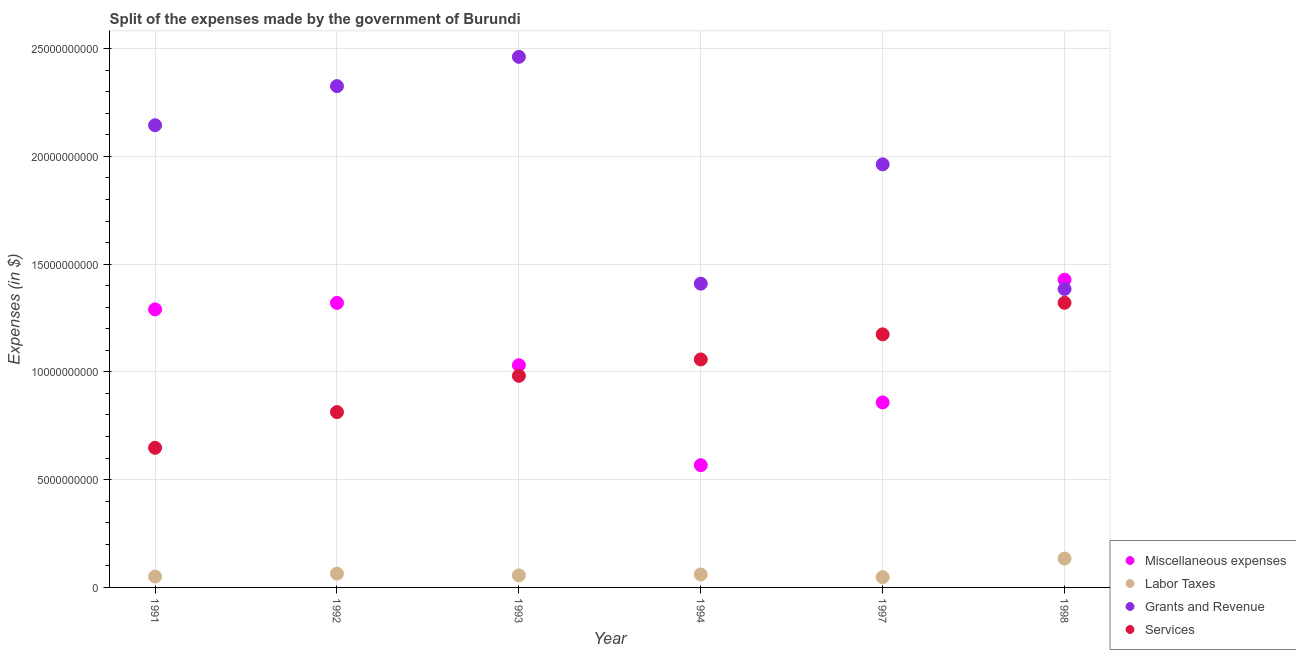Is the number of dotlines equal to the number of legend labels?
Your response must be concise. Yes. What is the amount spent on miscellaneous expenses in 1994?
Offer a very short reply. 5.67e+09. Across all years, what is the maximum amount spent on services?
Your answer should be very brief. 1.32e+1. Across all years, what is the minimum amount spent on services?
Offer a very short reply. 6.48e+09. In which year was the amount spent on grants and revenue minimum?
Your answer should be very brief. 1998. What is the total amount spent on services in the graph?
Provide a short and direct response. 6.00e+1. What is the difference between the amount spent on services in 1992 and that in 1997?
Keep it short and to the point. -3.61e+09. What is the difference between the amount spent on miscellaneous expenses in 1994 and the amount spent on services in 1998?
Keep it short and to the point. -7.53e+09. What is the average amount spent on miscellaneous expenses per year?
Your answer should be very brief. 1.08e+1. In the year 1992, what is the difference between the amount spent on labor taxes and amount spent on grants and revenue?
Offer a very short reply. -2.26e+1. In how many years, is the amount spent on miscellaneous expenses greater than 15000000000 $?
Your response must be concise. 0. What is the ratio of the amount spent on miscellaneous expenses in 1994 to that in 1997?
Provide a short and direct response. 0.66. Is the difference between the amount spent on labor taxes in 1994 and 1997 greater than the difference between the amount spent on services in 1994 and 1997?
Your response must be concise. Yes. What is the difference between the highest and the second highest amount spent on labor taxes?
Provide a succinct answer. 7.01e+08. What is the difference between the highest and the lowest amount spent on grants and revenue?
Ensure brevity in your answer.  1.08e+1. In how many years, is the amount spent on labor taxes greater than the average amount spent on labor taxes taken over all years?
Offer a terse response. 1. Is it the case that in every year, the sum of the amount spent on miscellaneous expenses and amount spent on services is greater than the sum of amount spent on grants and revenue and amount spent on labor taxes?
Provide a succinct answer. No. Is it the case that in every year, the sum of the amount spent on miscellaneous expenses and amount spent on labor taxes is greater than the amount spent on grants and revenue?
Offer a terse response. No. Is the amount spent on labor taxes strictly greater than the amount spent on miscellaneous expenses over the years?
Offer a very short reply. No. What is the difference between two consecutive major ticks on the Y-axis?
Provide a succinct answer. 5.00e+09. Are the values on the major ticks of Y-axis written in scientific E-notation?
Your answer should be compact. No. Does the graph contain any zero values?
Ensure brevity in your answer.  No. Does the graph contain grids?
Offer a terse response. Yes. How many legend labels are there?
Your answer should be very brief. 4. What is the title of the graph?
Offer a very short reply. Split of the expenses made by the government of Burundi. What is the label or title of the X-axis?
Offer a terse response. Year. What is the label or title of the Y-axis?
Provide a short and direct response. Expenses (in $). What is the Expenses (in $) of Miscellaneous expenses in 1991?
Your answer should be compact. 1.29e+1. What is the Expenses (in $) of Labor Taxes in 1991?
Provide a succinct answer. 5.03e+08. What is the Expenses (in $) of Grants and Revenue in 1991?
Ensure brevity in your answer.  2.14e+1. What is the Expenses (in $) of Services in 1991?
Give a very brief answer. 6.48e+09. What is the Expenses (in $) of Miscellaneous expenses in 1992?
Your answer should be compact. 1.32e+1. What is the Expenses (in $) in Labor Taxes in 1992?
Ensure brevity in your answer.  6.41e+08. What is the Expenses (in $) of Grants and Revenue in 1992?
Provide a short and direct response. 2.33e+1. What is the Expenses (in $) of Services in 1992?
Keep it short and to the point. 8.13e+09. What is the Expenses (in $) in Miscellaneous expenses in 1993?
Provide a short and direct response. 1.03e+1. What is the Expenses (in $) in Labor Taxes in 1993?
Your answer should be very brief. 5.60e+08. What is the Expenses (in $) of Grants and Revenue in 1993?
Your answer should be compact. 2.46e+1. What is the Expenses (in $) in Services in 1993?
Make the answer very short. 9.82e+09. What is the Expenses (in $) in Miscellaneous expenses in 1994?
Keep it short and to the point. 5.67e+09. What is the Expenses (in $) in Labor Taxes in 1994?
Provide a short and direct response. 6.03e+08. What is the Expenses (in $) in Grants and Revenue in 1994?
Ensure brevity in your answer.  1.41e+1. What is the Expenses (in $) of Services in 1994?
Give a very brief answer. 1.06e+1. What is the Expenses (in $) of Miscellaneous expenses in 1997?
Provide a short and direct response. 8.58e+09. What is the Expenses (in $) in Labor Taxes in 1997?
Provide a succinct answer. 4.75e+08. What is the Expenses (in $) of Grants and Revenue in 1997?
Your answer should be compact. 1.96e+1. What is the Expenses (in $) in Services in 1997?
Your answer should be compact. 1.17e+1. What is the Expenses (in $) in Miscellaneous expenses in 1998?
Provide a short and direct response. 1.43e+1. What is the Expenses (in $) in Labor Taxes in 1998?
Your answer should be compact. 1.34e+09. What is the Expenses (in $) in Grants and Revenue in 1998?
Provide a succinct answer. 1.38e+1. What is the Expenses (in $) of Services in 1998?
Ensure brevity in your answer.  1.32e+1. Across all years, what is the maximum Expenses (in $) of Miscellaneous expenses?
Provide a short and direct response. 1.43e+1. Across all years, what is the maximum Expenses (in $) of Labor Taxes?
Make the answer very short. 1.34e+09. Across all years, what is the maximum Expenses (in $) in Grants and Revenue?
Keep it short and to the point. 2.46e+1. Across all years, what is the maximum Expenses (in $) of Services?
Your answer should be very brief. 1.32e+1. Across all years, what is the minimum Expenses (in $) of Miscellaneous expenses?
Give a very brief answer. 5.67e+09. Across all years, what is the minimum Expenses (in $) of Labor Taxes?
Your answer should be compact. 4.75e+08. Across all years, what is the minimum Expenses (in $) of Grants and Revenue?
Give a very brief answer. 1.38e+1. Across all years, what is the minimum Expenses (in $) of Services?
Offer a terse response. 6.48e+09. What is the total Expenses (in $) in Miscellaneous expenses in the graph?
Provide a short and direct response. 6.49e+1. What is the total Expenses (in $) in Labor Taxes in the graph?
Make the answer very short. 4.12e+09. What is the total Expenses (in $) of Grants and Revenue in the graph?
Your answer should be compact. 1.17e+11. What is the total Expenses (in $) of Services in the graph?
Make the answer very short. 6.00e+1. What is the difference between the Expenses (in $) of Miscellaneous expenses in 1991 and that in 1992?
Keep it short and to the point. -3.00e+08. What is the difference between the Expenses (in $) of Labor Taxes in 1991 and that in 1992?
Your answer should be compact. -1.38e+08. What is the difference between the Expenses (in $) of Grants and Revenue in 1991 and that in 1992?
Give a very brief answer. -1.81e+09. What is the difference between the Expenses (in $) in Services in 1991 and that in 1992?
Ensure brevity in your answer.  -1.66e+09. What is the difference between the Expenses (in $) of Miscellaneous expenses in 1991 and that in 1993?
Provide a succinct answer. 2.59e+09. What is the difference between the Expenses (in $) in Labor Taxes in 1991 and that in 1993?
Offer a very short reply. -5.70e+07. What is the difference between the Expenses (in $) of Grants and Revenue in 1991 and that in 1993?
Your answer should be compact. -3.17e+09. What is the difference between the Expenses (in $) in Services in 1991 and that in 1993?
Your answer should be very brief. -3.34e+09. What is the difference between the Expenses (in $) in Miscellaneous expenses in 1991 and that in 1994?
Offer a terse response. 7.23e+09. What is the difference between the Expenses (in $) in Labor Taxes in 1991 and that in 1994?
Ensure brevity in your answer.  -1.00e+08. What is the difference between the Expenses (in $) of Grants and Revenue in 1991 and that in 1994?
Offer a terse response. 7.35e+09. What is the difference between the Expenses (in $) of Services in 1991 and that in 1994?
Provide a succinct answer. -4.10e+09. What is the difference between the Expenses (in $) of Miscellaneous expenses in 1991 and that in 1997?
Your answer should be compact. 4.32e+09. What is the difference between the Expenses (in $) in Labor Taxes in 1991 and that in 1997?
Give a very brief answer. 2.80e+07. What is the difference between the Expenses (in $) of Grants and Revenue in 1991 and that in 1997?
Make the answer very short. 1.81e+09. What is the difference between the Expenses (in $) of Services in 1991 and that in 1997?
Ensure brevity in your answer.  -5.26e+09. What is the difference between the Expenses (in $) in Miscellaneous expenses in 1991 and that in 1998?
Offer a terse response. -1.38e+09. What is the difference between the Expenses (in $) of Labor Taxes in 1991 and that in 1998?
Offer a very short reply. -8.39e+08. What is the difference between the Expenses (in $) in Grants and Revenue in 1991 and that in 1998?
Offer a very short reply. 7.60e+09. What is the difference between the Expenses (in $) in Services in 1991 and that in 1998?
Your answer should be compact. -6.73e+09. What is the difference between the Expenses (in $) in Miscellaneous expenses in 1992 and that in 1993?
Offer a very short reply. 2.89e+09. What is the difference between the Expenses (in $) of Labor Taxes in 1992 and that in 1993?
Your answer should be compact. 8.10e+07. What is the difference between the Expenses (in $) in Grants and Revenue in 1992 and that in 1993?
Your answer should be compact. -1.36e+09. What is the difference between the Expenses (in $) in Services in 1992 and that in 1993?
Ensure brevity in your answer.  -1.68e+09. What is the difference between the Expenses (in $) in Miscellaneous expenses in 1992 and that in 1994?
Offer a terse response. 7.53e+09. What is the difference between the Expenses (in $) in Labor Taxes in 1992 and that in 1994?
Make the answer very short. 3.80e+07. What is the difference between the Expenses (in $) of Grants and Revenue in 1992 and that in 1994?
Provide a short and direct response. 9.16e+09. What is the difference between the Expenses (in $) of Services in 1992 and that in 1994?
Offer a very short reply. -2.44e+09. What is the difference between the Expenses (in $) in Miscellaneous expenses in 1992 and that in 1997?
Offer a terse response. 4.62e+09. What is the difference between the Expenses (in $) in Labor Taxes in 1992 and that in 1997?
Make the answer very short. 1.66e+08. What is the difference between the Expenses (in $) of Grants and Revenue in 1992 and that in 1997?
Provide a succinct answer. 3.63e+09. What is the difference between the Expenses (in $) in Services in 1992 and that in 1997?
Your answer should be compact. -3.61e+09. What is the difference between the Expenses (in $) of Miscellaneous expenses in 1992 and that in 1998?
Your answer should be very brief. -1.08e+09. What is the difference between the Expenses (in $) in Labor Taxes in 1992 and that in 1998?
Give a very brief answer. -7.01e+08. What is the difference between the Expenses (in $) of Grants and Revenue in 1992 and that in 1998?
Offer a very short reply. 9.41e+09. What is the difference between the Expenses (in $) in Services in 1992 and that in 1998?
Your answer should be very brief. -5.07e+09. What is the difference between the Expenses (in $) in Miscellaneous expenses in 1993 and that in 1994?
Provide a short and direct response. 4.64e+09. What is the difference between the Expenses (in $) in Labor Taxes in 1993 and that in 1994?
Make the answer very short. -4.30e+07. What is the difference between the Expenses (in $) of Grants and Revenue in 1993 and that in 1994?
Provide a short and direct response. 1.05e+1. What is the difference between the Expenses (in $) of Services in 1993 and that in 1994?
Your response must be concise. -7.59e+08. What is the difference between the Expenses (in $) in Miscellaneous expenses in 1993 and that in 1997?
Your answer should be very brief. 1.72e+09. What is the difference between the Expenses (in $) in Labor Taxes in 1993 and that in 1997?
Make the answer very short. 8.50e+07. What is the difference between the Expenses (in $) in Grants and Revenue in 1993 and that in 1997?
Your answer should be compact. 4.99e+09. What is the difference between the Expenses (in $) of Services in 1993 and that in 1997?
Provide a succinct answer. -1.92e+09. What is the difference between the Expenses (in $) of Miscellaneous expenses in 1993 and that in 1998?
Provide a short and direct response. -3.97e+09. What is the difference between the Expenses (in $) in Labor Taxes in 1993 and that in 1998?
Offer a very short reply. -7.82e+08. What is the difference between the Expenses (in $) of Grants and Revenue in 1993 and that in 1998?
Give a very brief answer. 1.08e+1. What is the difference between the Expenses (in $) in Services in 1993 and that in 1998?
Offer a terse response. -3.39e+09. What is the difference between the Expenses (in $) in Miscellaneous expenses in 1994 and that in 1997?
Keep it short and to the point. -2.91e+09. What is the difference between the Expenses (in $) in Labor Taxes in 1994 and that in 1997?
Make the answer very short. 1.28e+08. What is the difference between the Expenses (in $) in Grants and Revenue in 1994 and that in 1997?
Make the answer very short. -5.54e+09. What is the difference between the Expenses (in $) of Services in 1994 and that in 1997?
Make the answer very short. -1.16e+09. What is the difference between the Expenses (in $) of Miscellaneous expenses in 1994 and that in 1998?
Provide a succinct answer. -8.60e+09. What is the difference between the Expenses (in $) of Labor Taxes in 1994 and that in 1998?
Your answer should be very brief. -7.39e+08. What is the difference between the Expenses (in $) in Grants and Revenue in 1994 and that in 1998?
Provide a short and direct response. 2.46e+08. What is the difference between the Expenses (in $) of Services in 1994 and that in 1998?
Ensure brevity in your answer.  -2.63e+09. What is the difference between the Expenses (in $) in Miscellaneous expenses in 1997 and that in 1998?
Keep it short and to the point. -5.69e+09. What is the difference between the Expenses (in $) of Labor Taxes in 1997 and that in 1998?
Give a very brief answer. -8.67e+08. What is the difference between the Expenses (in $) in Grants and Revenue in 1997 and that in 1998?
Your answer should be compact. 5.78e+09. What is the difference between the Expenses (in $) in Services in 1997 and that in 1998?
Provide a succinct answer. -1.46e+09. What is the difference between the Expenses (in $) of Miscellaneous expenses in 1991 and the Expenses (in $) of Labor Taxes in 1992?
Offer a terse response. 1.23e+1. What is the difference between the Expenses (in $) in Miscellaneous expenses in 1991 and the Expenses (in $) in Grants and Revenue in 1992?
Provide a succinct answer. -1.04e+1. What is the difference between the Expenses (in $) in Miscellaneous expenses in 1991 and the Expenses (in $) in Services in 1992?
Give a very brief answer. 4.77e+09. What is the difference between the Expenses (in $) of Labor Taxes in 1991 and the Expenses (in $) of Grants and Revenue in 1992?
Your answer should be very brief. -2.28e+1. What is the difference between the Expenses (in $) of Labor Taxes in 1991 and the Expenses (in $) of Services in 1992?
Ensure brevity in your answer.  -7.63e+09. What is the difference between the Expenses (in $) of Grants and Revenue in 1991 and the Expenses (in $) of Services in 1992?
Make the answer very short. 1.33e+1. What is the difference between the Expenses (in $) in Miscellaneous expenses in 1991 and the Expenses (in $) in Labor Taxes in 1993?
Offer a terse response. 1.23e+1. What is the difference between the Expenses (in $) in Miscellaneous expenses in 1991 and the Expenses (in $) in Grants and Revenue in 1993?
Make the answer very short. -1.17e+1. What is the difference between the Expenses (in $) of Miscellaneous expenses in 1991 and the Expenses (in $) of Services in 1993?
Make the answer very short. 3.08e+09. What is the difference between the Expenses (in $) in Labor Taxes in 1991 and the Expenses (in $) in Grants and Revenue in 1993?
Your response must be concise. -2.41e+1. What is the difference between the Expenses (in $) in Labor Taxes in 1991 and the Expenses (in $) in Services in 1993?
Your answer should be very brief. -9.32e+09. What is the difference between the Expenses (in $) of Grants and Revenue in 1991 and the Expenses (in $) of Services in 1993?
Provide a succinct answer. 1.16e+1. What is the difference between the Expenses (in $) of Miscellaneous expenses in 1991 and the Expenses (in $) of Labor Taxes in 1994?
Ensure brevity in your answer.  1.23e+1. What is the difference between the Expenses (in $) in Miscellaneous expenses in 1991 and the Expenses (in $) in Grants and Revenue in 1994?
Your answer should be compact. -1.19e+09. What is the difference between the Expenses (in $) in Miscellaneous expenses in 1991 and the Expenses (in $) in Services in 1994?
Your answer should be very brief. 2.32e+09. What is the difference between the Expenses (in $) of Labor Taxes in 1991 and the Expenses (in $) of Grants and Revenue in 1994?
Keep it short and to the point. -1.36e+1. What is the difference between the Expenses (in $) of Labor Taxes in 1991 and the Expenses (in $) of Services in 1994?
Make the answer very short. -1.01e+1. What is the difference between the Expenses (in $) of Grants and Revenue in 1991 and the Expenses (in $) of Services in 1994?
Make the answer very short. 1.09e+1. What is the difference between the Expenses (in $) of Miscellaneous expenses in 1991 and the Expenses (in $) of Labor Taxes in 1997?
Your answer should be compact. 1.24e+1. What is the difference between the Expenses (in $) in Miscellaneous expenses in 1991 and the Expenses (in $) in Grants and Revenue in 1997?
Your response must be concise. -6.73e+09. What is the difference between the Expenses (in $) in Miscellaneous expenses in 1991 and the Expenses (in $) in Services in 1997?
Give a very brief answer. 1.16e+09. What is the difference between the Expenses (in $) in Labor Taxes in 1991 and the Expenses (in $) in Grants and Revenue in 1997?
Make the answer very short. -1.91e+1. What is the difference between the Expenses (in $) in Labor Taxes in 1991 and the Expenses (in $) in Services in 1997?
Provide a succinct answer. -1.12e+1. What is the difference between the Expenses (in $) in Grants and Revenue in 1991 and the Expenses (in $) in Services in 1997?
Offer a terse response. 9.70e+09. What is the difference between the Expenses (in $) in Miscellaneous expenses in 1991 and the Expenses (in $) in Labor Taxes in 1998?
Your response must be concise. 1.16e+1. What is the difference between the Expenses (in $) of Miscellaneous expenses in 1991 and the Expenses (in $) of Grants and Revenue in 1998?
Your response must be concise. -9.47e+08. What is the difference between the Expenses (in $) in Miscellaneous expenses in 1991 and the Expenses (in $) in Services in 1998?
Offer a terse response. -3.05e+08. What is the difference between the Expenses (in $) in Labor Taxes in 1991 and the Expenses (in $) in Grants and Revenue in 1998?
Provide a succinct answer. -1.33e+1. What is the difference between the Expenses (in $) in Labor Taxes in 1991 and the Expenses (in $) in Services in 1998?
Offer a terse response. -1.27e+1. What is the difference between the Expenses (in $) in Grants and Revenue in 1991 and the Expenses (in $) in Services in 1998?
Your answer should be very brief. 8.24e+09. What is the difference between the Expenses (in $) of Miscellaneous expenses in 1992 and the Expenses (in $) of Labor Taxes in 1993?
Give a very brief answer. 1.26e+1. What is the difference between the Expenses (in $) in Miscellaneous expenses in 1992 and the Expenses (in $) in Grants and Revenue in 1993?
Your response must be concise. -1.14e+1. What is the difference between the Expenses (in $) in Miscellaneous expenses in 1992 and the Expenses (in $) in Services in 1993?
Give a very brief answer. 3.38e+09. What is the difference between the Expenses (in $) in Labor Taxes in 1992 and the Expenses (in $) in Grants and Revenue in 1993?
Offer a very short reply. -2.40e+1. What is the difference between the Expenses (in $) of Labor Taxes in 1992 and the Expenses (in $) of Services in 1993?
Give a very brief answer. -9.18e+09. What is the difference between the Expenses (in $) of Grants and Revenue in 1992 and the Expenses (in $) of Services in 1993?
Offer a very short reply. 1.34e+1. What is the difference between the Expenses (in $) of Miscellaneous expenses in 1992 and the Expenses (in $) of Labor Taxes in 1994?
Offer a very short reply. 1.26e+1. What is the difference between the Expenses (in $) of Miscellaneous expenses in 1992 and the Expenses (in $) of Grants and Revenue in 1994?
Ensure brevity in your answer.  -8.93e+08. What is the difference between the Expenses (in $) in Miscellaneous expenses in 1992 and the Expenses (in $) in Services in 1994?
Keep it short and to the point. 2.62e+09. What is the difference between the Expenses (in $) in Labor Taxes in 1992 and the Expenses (in $) in Grants and Revenue in 1994?
Offer a very short reply. -1.35e+1. What is the difference between the Expenses (in $) of Labor Taxes in 1992 and the Expenses (in $) of Services in 1994?
Provide a short and direct response. -9.94e+09. What is the difference between the Expenses (in $) in Grants and Revenue in 1992 and the Expenses (in $) in Services in 1994?
Offer a very short reply. 1.27e+1. What is the difference between the Expenses (in $) in Miscellaneous expenses in 1992 and the Expenses (in $) in Labor Taxes in 1997?
Make the answer very short. 1.27e+1. What is the difference between the Expenses (in $) in Miscellaneous expenses in 1992 and the Expenses (in $) in Grants and Revenue in 1997?
Your answer should be compact. -6.43e+09. What is the difference between the Expenses (in $) of Miscellaneous expenses in 1992 and the Expenses (in $) of Services in 1997?
Make the answer very short. 1.46e+09. What is the difference between the Expenses (in $) of Labor Taxes in 1992 and the Expenses (in $) of Grants and Revenue in 1997?
Provide a succinct answer. -1.90e+1. What is the difference between the Expenses (in $) of Labor Taxes in 1992 and the Expenses (in $) of Services in 1997?
Offer a very short reply. -1.11e+1. What is the difference between the Expenses (in $) in Grants and Revenue in 1992 and the Expenses (in $) in Services in 1997?
Make the answer very short. 1.15e+1. What is the difference between the Expenses (in $) of Miscellaneous expenses in 1992 and the Expenses (in $) of Labor Taxes in 1998?
Your answer should be compact. 1.19e+1. What is the difference between the Expenses (in $) in Miscellaneous expenses in 1992 and the Expenses (in $) in Grants and Revenue in 1998?
Provide a succinct answer. -6.47e+08. What is the difference between the Expenses (in $) in Miscellaneous expenses in 1992 and the Expenses (in $) in Services in 1998?
Offer a very short reply. -5.00e+06. What is the difference between the Expenses (in $) in Labor Taxes in 1992 and the Expenses (in $) in Grants and Revenue in 1998?
Give a very brief answer. -1.32e+1. What is the difference between the Expenses (in $) in Labor Taxes in 1992 and the Expenses (in $) in Services in 1998?
Give a very brief answer. -1.26e+1. What is the difference between the Expenses (in $) in Grants and Revenue in 1992 and the Expenses (in $) in Services in 1998?
Provide a succinct answer. 1.01e+1. What is the difference between the Expenses (in $) of Miscellaneous expenses in 1993 and the Expenses (in $) of Labor Taxes in 1994?
Your answer should be very brief. 9.70e+09. What is the difference between the Expenses (in $) in Miscellaneous expenses in 1993 and the Expenses (in $) in Grants and Revenue in 1994?
Your response must be concise. -3.78e+09. What is the difference between the Expenses (in $) of Miscellaneous expenses in 1993 and the Expenses (in $) of Services in 1994?
Your answer should be compact. -2.69e+08. What is the difference between the Expenses (in $) in Labor Taxes in 1993 and the Expenses (in $) in Grants and Revenue in 1994?
Make the answer very short. -1.35e+1. What is the difference between the Expenses (in $) of Labor Taxes in 1993 and the Expenses (in $) of Services in 1994?
Keep it short and to the point. -1.00e+1. What is the difference between the Expenses (in $) of Grants and Revenue in 1993 and the Expenses (in $) of Services in 1994?
Offer a very short reply. 1.40e+1. What is the difference between the Expenses (in $) in Miscellaneous expenses in 1993 and the Expenses (in $) in Labor Taxes in 1997?
Your answer should be compact. 9.83e+09. What is the difference between the Expenses (in $) in Miscellaneous expenses in 1993 and the Expenses (in $) in Grants and Revenue in 1997?
Your answer should be compact. -9.32e+09. What is the difference between the Expenses (in $) of Miscellaneous expenses in 1993 and the Expenses (in $) of Services in 1997?
Provide a succinct answer. -1.43e+09. What is the difference between the Expenses (in $) of Labor Taxes in 1993 and the Expenses (in $) of Grants and Revenue in 1997?
Give a very brief answer. -1.91e+1. What is the difference between the Expenses (in $) of Labor Taxes in 1993 and the Expenses (in $) of Services in 1997?
Keep it short and to the point. -1.12e+1. What is the difference between the Expenses (in $) of Grants and Revenue in 1993 and the Expenses (in $) of Services in 1997?
Offer a very short reply. 1.29e+1. What is the difference between the Expenses (in $) in Miscellaneous expenses in 1993 and the Expenses (in $) in Labor Taxes in 1998?
Your answer should be very brief. 8.97e+09. What is the difference between the Expenses (in $) of Miscellaneous expenses in 1993 and the Expenses (in $) of Grants and Revenue in 1998?
Your answer should be compact. -3.54e+09. What is the difference between the Expenses (in $) in Miscellaneous expenses in 1993 and the Expenses (in $) in Services in 1998?
Your answer should be very brief. -2.90e+09. What is the difference between the Expenses (in $) of Labor Taxes in 1993 and the Expenses (in $) of Grants and Revenue in 1998?
Give a very brief answer. -1.33e+1. What is the difference between the Expenses (in $) of Labor Taxes in 1993 and the Expenses (in $) of Services in 1998?
Provide a short and direct response. -1.26e+1. What is the difference between the Expenses (in $) in Grants and Revenue in 1993 and the Expenses (in $) in Services in 1998?
Provide a succinct answer. 1.14e+1. What is the difference between the Expenses (in $) in Miscellaneous expenses in 1994 and the Expenses (in $) in Labor Taxes in 1997?
Provide a short and direct response. 5.20e+09. What is the difference between the Expenses (in $) of Miscellaneous expenses in 1994 and the Expenses (in $) of Grants and Revenue in 1997?
Your answer should be very brief. -1.40e+1. What is the difference between the Expenses (in $) of Miscellaneous expenses in 1994 and the Expenses (in $) of Services in 1997?
Offer a very short reply. -6.07e+09. What is the difference between the Expenses (in $) of Labor Taxes in 1994 and the Expenses (in $) of Grants and Revenue in 1997?
Give a very brief answer. -1.90e+1. What is the difference between the Expenses (in $) of Labor Taxes in 1994 and the Expenses (in $) of Services in 1997?
Your answer should be compact. -1.11e+1. What is the difference between the Expenses (in $) in Grants and Revenue in 1994 and the Expenses (in $) in Services in 1997?
Your answer should be compact. 2.35e+09. What is the difference between the Expenses (in $) of Miscellaneous expenses in 1994 and the Expenses (in $) of Labor Taxes in 1998?
Your answer should be compact. 4.33e+09. What is the difference between the Expenses (in $) in Miscellaneous expenses in 1994 and the Expenses (in $) in Grants and Revenue in 1998?
Keep it short and to the point. -8.18e+09. What is the difference between the Expenses (in $) of Miscellaneous expenses in 1994 and the Expenses (in $) of Services in 1998?
Make the answer very short. -7.53e+09. What is the difference between the Expenses (in $) of Labor Taxes in 1994 and the Expenses (in $) of Grants and Revenue in 1998?
Provide a short and direct response. -1.32e+1. What is the difference between the Expenses (in $) in Labor Taxes in 1994 and the Expenses (in $) in Services in 1998?
Make the answer very short. -1.26e+1. What is the difference between the Expenses (in $) of Grants and Revenue in 1994 and the Expenses (in $) of Services in 1998?
Your response must be concise. 8.88e+08. What is the difference between the Expenses (in $) of Miscellaneous expenses in 1997 and the Expenses (in $) of Labor Taxes in 1998?
Offer a very short reply. 7.24e+09. What is the difference between the Expenses (in $) in Miscellaneous expenses in 1997 and the Expenses (in $) in Grants and Revenue in 1998?
Provide a succinct answer. -5.26e+09. What is the difference between the Expenses (in $) in Miscellaneous expenses in 1997 and the Expenses (in $) in Services in 1998?
Provide a short and direct response. -4.62e+09. What is the difference between the Expenses (in $) of Labor Taxes in 1997 and the Expenses (in $) of Grants and Revenue in 1998?
Provide a succinct answer. -1.34e+1. What is the difference between the Expenses (in $) of Labor Taxes in 1997 and the Expenses (in $) of Services in 1998?
Offer a very short reply. -1.27e+1. What is the difference between the Expenses (in $) of Grants and Revenue in 1997 and the Expenses (in $) of Services in 1998?
Offer a terse response. 6.42e+09. What is the average Expenses (in $) of Miscellaneous expenses per year?
Your response must be concise. 1.08e+1. What is the average Expenses (in $) in Labor Taxes per year?
Your answer should be compact. 6.87e+08. What is the average Expenses (in $) in Grants and Revenue per year?
Provide a short and direct response. 1.95e+1. What is the average Expenses (in $) in Services per year?
Offer a terse response. 9.99e+09. In the year 1991, what is the difference between the Expenses (in $) in Miscellaneous expenses and Expenses (in $) in Labor Taxes?
Offer a very short reply. 1.24e+1. In the year 1991, what is the difference between the Expenses (in $) of Miscellaneous expenses and Expenses (in $) of Grants and Revenue?
Provide a short and direct response. -8.54e+09. In the year 1991, what is the difference between the Expenses (in $) of Miscellaneous expenses and Expenses (in $) of Services?
Provide a succinct answer. 6.42e+09. In the year 1991, what is the difference between the Expenses (in $) in Labor Taxes and Expenses (in $) in Grants and Revenue?
Your answer should be very brief. -2.09e+1. In the year 1991, what is the difference between the Expenses (in $) of Labor Taxes and Expenses (in $) of Services?
Make the answer very short. -5.98e+09. In the year 1991, what is the difference between the Expenses (in $) in Grants and Revenue and Expenses (in $) in Services?
Your response must be concise. 1.50e+1. In the year 1992, what is the difference between the Expenses (in $) of Miscellaneous expenses and Expenses (in $) of Labor Taxes?
Your answer should be very brief. 1.26e+1. In the year 1992, what is the difference between the Expenses (in $) in Miscellaneous expenses and Expenses (in $) in Grants and Revenue?
Offer a terse response. -1.01e+1. In the year 1992, what is the difference between the Expenses (in $) in Miscellaneous expenses and Expenses (in $) in Services?
Make the answer very short. 5.07e+09. In the year 1992, what is the difference between the Expenses (in $) in Labor Taxes and Expenses (in $) in Grants and Revenue?
Offer a very short reply. -2.26e+1. In the year 1992, what is the difference between the Expenses (in $) of Labor Taxes and Expenses (in $) of Services?
Your answer should be very brief. -7.49e+09. In the year 1992, what is the difference between the Expenses (in $) in Grants and Revenue and Expenses (in $) in Services?
Provide a short and direct response. 1.51e+1. In the year 1993, what is the difference between the Expenses (in $) in Miscellaneous expenses and Expenses (in $) in Labor Taxes?
Ensure brevity in your answer.  9.75e+09. In the year 1993, what is the difference between the Expenses (in $) in Miscellaneous expenses and Expenses (in $) in Grants and Revenue?
Offer a terse response. -1.43e+1. In the year 1993, what is the difference between the Expenses (in $) in Miscellaneous expenses and Expenses (in $) in Services?
Make the answer very short. 4.90e+08. In the year 1993, what is the difference between the Expenses (in $) of Labor Taxes and Expenses (in $) of Grants and Revenue?
Your answer should be compact. -2.41e+1. In the year 1993, what is the difference between the Expenses (in $) in Labor Taxes and Expenses (in $) in Services?
Give a very brief answer. -9.26e+09. In the year 1993, what is the difference between the Expenses (in $) in Grants and Revenue and Expenses (in $) in Services?
Give a very brief answer. 1.48e+1. In the year 1994, what is the difference between the Expenses (in $) in Miscellaneous expenses and Expenses (in $) in Labor Taxes?
Your answer should be compact. 5.07e+09. In the year 1994, what is the difference between the Expenses (in $) in Miscellaneous expenses and Expenses (in $) in Grants and Revenue?
Ensure brevity in your answer.  -8.42e+09. In the year 1994, what is the difference between the Expenses (in $) in Miscellaneous expenses and Expenses (in $) in Services?
Give a very brief answer. -4.90e+09. In the year 1994, what is the difference between the Expenses (in $) in Labor Taxes and Expenses (in $) in Grants and Revenue?
Provide a short and direct response. -1.35e+1. In the year 1994, what is the difference between the Expenses (in $) in Labor Taxes and Expenses (in $) in Services?
Your response must be concise. -9.97e+09. In the year 1994, what is the difference between the Expenses (in $) in Grants and Revenue and Expenses (in $) in Services?
Ensure brevity in your answer.  3.52e+09. In the year 1997, what is the difference between the Expenses (in $) in Miscellaneous expenses and Expenses (in $) in Labor Taxes?
Ensure brevity in your answer.  8.11e+09. In the year 1997, what is the difference between the Expenses (in $) of Miscellaneous expenses and Expenses (in $) of Grants and Revenue?
Give a very brief answer. -1.10e+1. In the year 1997, what is the difference between the Expenses (in $) in Miscellaneous expenses and Expenses (in $) in Services?
Make the answer very short. -3.16e+09. In the year 1997, what is the difference between the Expenses (in $) of Labor Taxes and Expenses (in $) of Grants and Revenue?
Keep it short and to the point. -1.92e+1. In the year 1997, what is the difference between the Expenses (in $) of Labor Taxes and Expenses (in $) of Services?
Ensure brevity in your answer.  -1.13e+1. In the year 1997, what is the difference between the Expenses (in $) in Grants and Revenue and Expenses (in $) in Services?
Provide a succinct answer. 7.89e+09. In the year 1998, what is the difference between the Expenses (in $) of Miscellaneous expenses and Expenses (in $) of Labor Taxes?
Provide a succinct answer. 1.29e+1. In the year 1998, what is the difference between the Expenses (in $) in Miscellaneous expenses and Expenses (in $) in Grants and Revenue?
Your answer should be compact. 4.28e+08. In the year 1998, what is the difference between the Expenses (in $) of Miscellaneous expenses and Expenses (in $) of Services?
Offer a terse response. 1.07e+09. In the year 1998, what is the difference between the Expenses (in $) in Labor Taxes and Expenses (in $) in Grants and Revenue?
Give a very brief answer. -1.25e+1. In the year 1998, what is the difference between the Expenses (in $) in Labor Taxes and Expenses (in $) in Services?
Your answer should be very brief. -1.19e+1. In the year 1998, what is the difference between the Expenses (in $) in Grants and Revenue and Expenses (in $) in Services?
Make the answer very short. 6.42e+08. What is the ratio of the Expenses (in $) in Miscellaneous expenses in 1991 to that in 1992?
Give a very brief answer. 0.98. What is the ratio of the Expenses (in $) of Labor Taxes in 1991 to that in 1992?
Offer a terse response. 0.78. What is the ratio of the Expenses (in $) in Grants and Revenue in 1991 to that in 1992?
Your answer should be compact. 0.92. What is the ratio of the Expenses (in $) of Services in 1991 to that in 1992?
Keep it short and to the point. 0.8. What is the ratio of the Expenses (in $) in Miscellaneous expenses in 1991 to that in 1993?
Provide a succinct answer. 1.25. What is the ratio of the Expenses (in $) of Labor Taxes in 1991 to that in 1993?
Your answer should be compact. 0.9. What is the ratio of the Expenses (in $) of Grants and Revenue in 1991 to that in 1993?
Your answer should be compact. 0.87. What is the ratio of the Expenses (in $) in Services in 1991 to that in 1993?
Ensure brevity in your answer.  0.66. What is the ratio of the Expenses (in $) in Miscellaneous expenses in 1991 to that in 1994?
Your response must be concise. 2.27. What is the ratio of the Expenses (in $) in Labor Taxes in 1991 to that in 1994?
Provide a short and direct response. 0.83. What is the ratio of the Expenses (in $) in Grants and Revenue in 1991 to that in 1994?
Provide a succinct answer. 1.52. What is the ratio of the Expenses (in $) of Services in 1991 to that in 1994?
Ensure brevity in your answer.  0.61. What is the ratio of the Expenses (in $) in Miscellaneous expenses in 1991 to that in 1997?
Provide a short and direct response. 1.5. What is the ratio of the Expenses (in $) in Labor Taxes in 1991 to that in 1997?
Offer a very short reply. 1.06. What is the ratio of the Expenses (in $) in Grants and Revenue in 1991 to that in 1997?
Offer a very short reply. 1.09. What is the ratio of the Expenses (in $) in Services in 1991 to that in 1997?
Provide a short and direct response. 0.55. What is the ratio of the Expenses (in $) in Miscellaneous expenses in 1991 to that in 1998?
Provide a short and direct response. 0.9. What is the ratio of the Expenses (in $) of Labor Taxes in 1991 to that in 1998?
Your answer should be compact. 0.37. What is the ratio of the Expenses (in $) of Grants and Revenue in 1991 to that in 1998?
Offer a very short reply. 1.55. What is the ratio of the Expenses (in $) of Services in 1991 to that in 1998?
Ensure brevity in your answer.  0.49. What is the ratio of the Expenses (in $) of Miscellaneous expenses in 1992 to that in 1993?
Your response must be concise. 1.28. What is the ratio of the Expenses (in $) in Labor Taxes in 1992 to that in 1993?
Make the answer very short. 1.14. What is the ratio of the Expenses (in $) of Grants and Revenue in 1992 to that in 1993?
Offer a terse response. 0.94. What is the ratio of the Expenses (in $) in Services in 1992 to that in 1993?
Provide a succinct answer. 0.83. What is the ratio of the Expenses (in $) of Miscellaneous expenses in 1992 to that in 1994?
Your answer should be compact. 2.33. What is the ratio of the Expenses (in $) of Labor Taxes in 1992 to that in 1994?
Your answer should be very brief. 1.06. What is the ratio of the Expenses (in $) of Grants and Revenue in 1992 to that in 1994?
Keep it short and to the point. 1.65. What is the ratio of the Expenses (in $) in Services in 1992 to that in 1994?
Offer a terse response. 0.77. What is the ratio of the Expenses (in $) in Miscellaneous expenses in 1992 to that in 1997?
Give a very brief answer. 1.54. What is the ratio of the Expenses (in $) in Labor Taxes in 1992 to that in 1997?
Your answer should be compact. 1.35. What is the ratio of the Expenses (in $) in Grants and Revenue in 1992 to that in 1997?
Your response must be concise. 1.18. What is the ratio of the Expenses (in $) of Services in 1992 to that in 1997?
Provide a short and direct response. 0.69. What is the ratio of the Expenses (in $) of Miscellaneous expenses in 1992 to that in 1998?
Keep it short and to the point. 0.92. What is the ratio of the Expenses (in $) of Labor Taxes in 1992 to that in 1998?
Give a very brief answer. 0.48. What is the ratio of the Expenses (in $) in Grants and Revenue in 1992 to that in 1998?
Your answer should be compact. 1.68. What is the ratio of the Expenses (in $) in Services in 1992 to that in 1998?
Your answer should be compact. 0.62. What is the ratio of the Expenses (in $) of Miscellaneous expenses in 1993 to that in 1994?
Provide a succinct answer. 1.82. What is the ratio of the Expenses (in $) in Labor Taxes in 1993 to that in 1994?
Your response must be concise. 0.93. What is the ratio of the Expenses (in $) of Grants and Revenue in 1993 to that in 1994?
Offer a very short reply. 1.75. What is the ratio of the Expenses (in $) in Services in 1993 to that in 1994?
Make the answer very short. 0.93. What is the ratio of the Expenses (in $) of Miscellaneous expenses in 1993 to that in 1997?
Your response must be concise. 1.2. What is the ratio of the Expenses (in $) of Labor Taxes in 1993 to that in 1997?
Offer a terse response. 1.18. What is the ratio of the Expenses (in $) of Grants and Revenue in 1993 to that in 1997?
Keep it short and to the point. 1.25. What is the ratio of the Expenses (in $) in Services in 1993 to that in 1997?
Offer a terse response. 0.84. What is the ratio of the Expenses (in $) in Miscellaneous expenses in 1993 to that in 1998?
Your answer should be very brief. 0.72. What is the ratio of the Expenses (in $) of Labor Taxes in 1993 to that in 1998?
Keep it short and to the point. 0.42. What is the ratio of the Expenses (in $) in Grants and Revenue in 1993 to that in 1998?
Your response must be concise. 1.78. What is the ratio of the Expenses (in $) of Services in 1993 to that in 1998?
Make the answer very short. 0.74. What is the ratio of the Expenses (in $) in Miscellaneous expenses in 1994 to that in 1997?
Your answer should be compact. 0.66. What is the ratio of the Expenses (in $) of Labor Taxes in 1994 to that in 1997?
Make the answer very short. 1.27. What is the ratio of the Expenses (in $) of Grants and Revenue in 1994 to that in 1997?
Offer a terse response. 0.72. What is the ratio of the Expenses (in $) of Services in 1994 to that in 1997?
Offer a very short reply. 0.9. What is the ratio of the Expenses (in $) in Miscellaneous expenses in 1994 to that in 1998?
Provide a short and direct response. 0.4. What is the ratio of the Expenses (in $) in Labor Taxes in 1994 to that in 1998?
Give a very brief answer. 0.45. What is the ratio of the Expenses (in $) in Grants and Revenue in 1994 to that in 1998?
Offer a terse response. 1.02. What is the ratio of the Expenses (in $) in Services in 1994 to that in 1998?
Ensure brevity in your answer.  0.8. What is the ratio of the Expenses (in $) in Miscellaneous expenses in 1997 to that in 1998?
Your answer should be compact. 0.6. What is the ratio of the Expenses (in $) in Labor Taxes in 1997 to that in 1998?
Offer a terse response. 0.35. What is the ratio of the Expenses (in $) of Grants and Revenue in 1997 to that in 1998?
Your answer should be compact. 1.42. What is the ratio of the Expenses (in $) of Services in 1997 to that in 1998?
Give a very brief answer. 0.89. What is the difference between the highest and the second highest Expenses (in $) in Miscellaneous expenses?
Your answer should be very brief. 1.08e+09. What is the difference between the highest and the second highest Expenses (in $) of Labor Taxes?
Provide a succinct answer. 7.01e+08. What is the difference between the highest and the second highest Expenses (in $) of Grants and Revenue?
Your answer should be very brief. 1.36e+09. What is the difference between the highest and the second highest Expenses (in $) of Services?
Provide a succinct answer. 1.46e+09. What is the difference between the highest and the lowest Expenses (in $) of Miscellaneous expenses?
Give a very brief answer. 8.60e+09. What is the difference between the highest and the lowest Expenses (in $) of Labor Taxes?
Your answer should be compact. 8.67e+08. What is the difference between the highest and the lowest Expenses (in $) of Grants and Revenue?
Give a very brief answer. 1.08e+1. What is the difference between the highest and the lowest Expenses (in $) of Services?
Your response must be concise. 6.73e+09. 